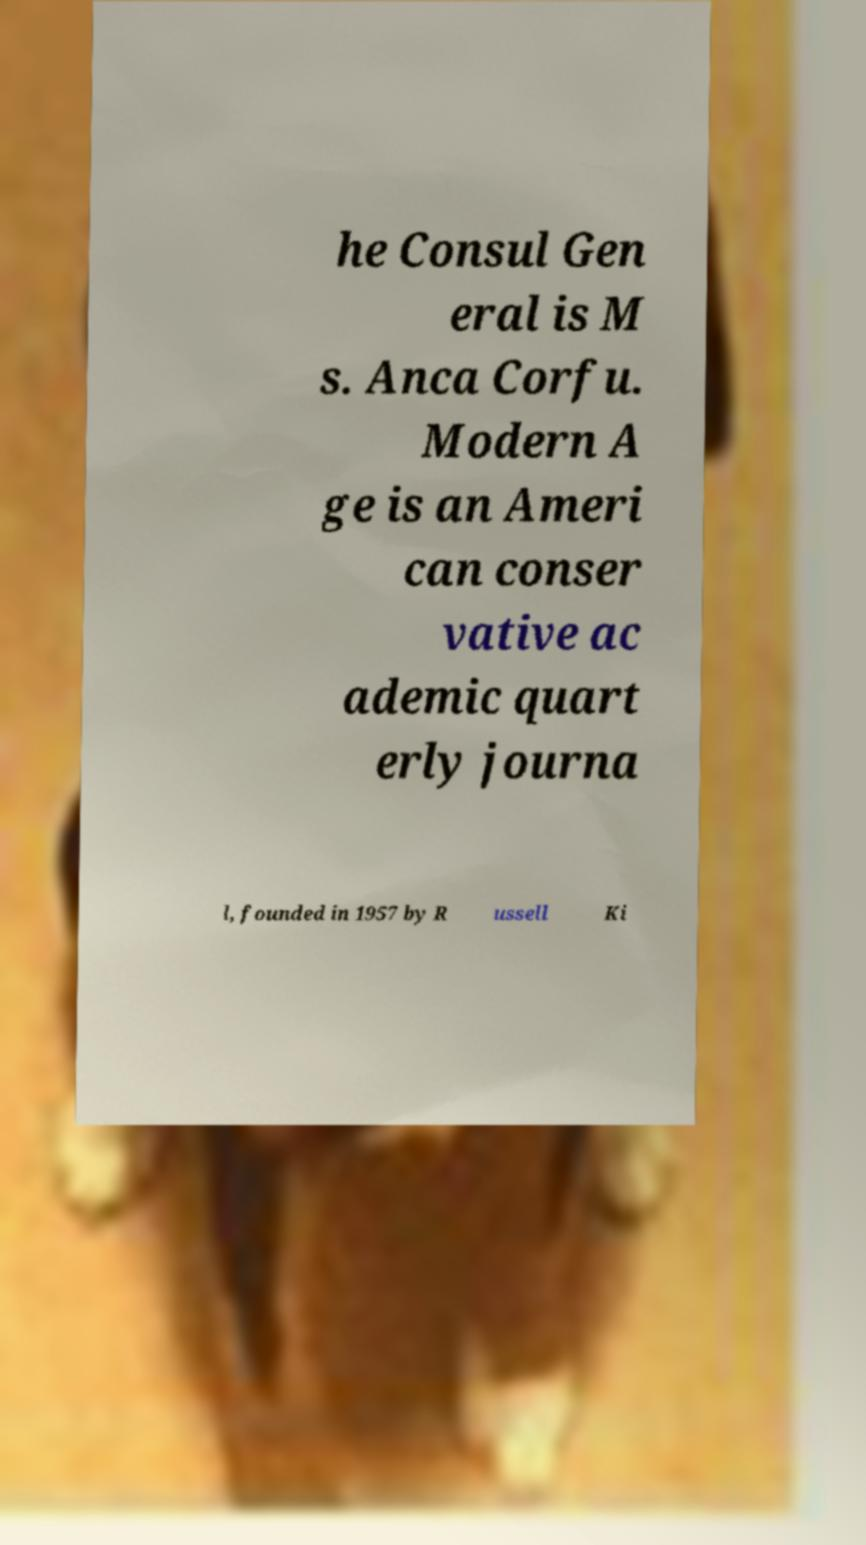For documentation purposes, I need the text within this image transcribed. Could you provide that? he Consul Gen eral is M s. Anca Corfu. Modern A ge is an Ameri can conser vative ac ademic quart erly journa l, founded in 1957 by R ussell Ki 